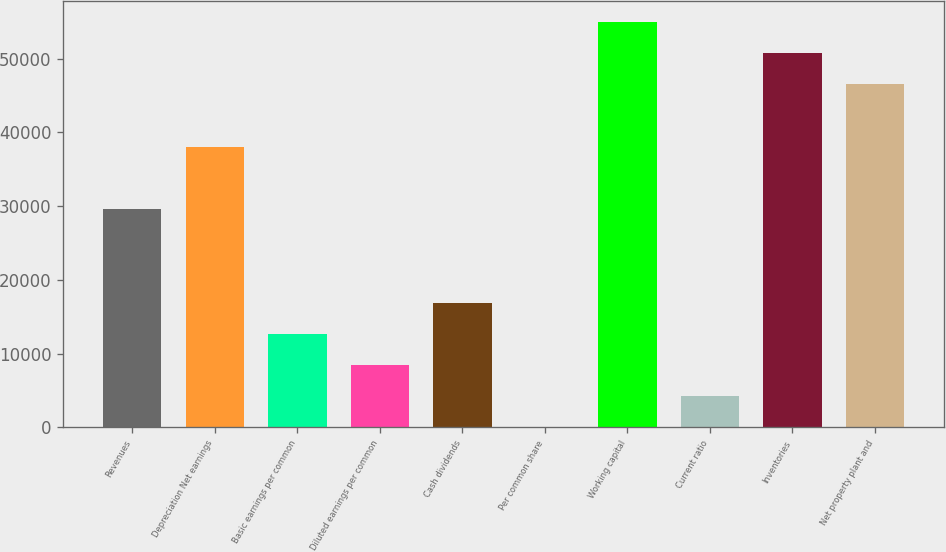Convert chart to OTSL. <chart><loc_0><loc_0><loc_500><loc_500><bar_chart><fcel>Revenues<fcel>Depreciation Net earnings<fcel>Basic earnings per common<fcel>Diluted earnings per common<fcel>Cash dividends<fcel>Per common share<fcel>Working capital<fcel>Current ratio<fcel>Inventories<fcel>Net property plant and<nl><fcel>29617.2<fcel>38079.1<fcel>12693.4<fcel>8462.5<fcel>16924.4<fcel>0.62<fcel>55002.8<fcel>4231.56<fcel>50771.9<fcel>46541<nl></chart> 